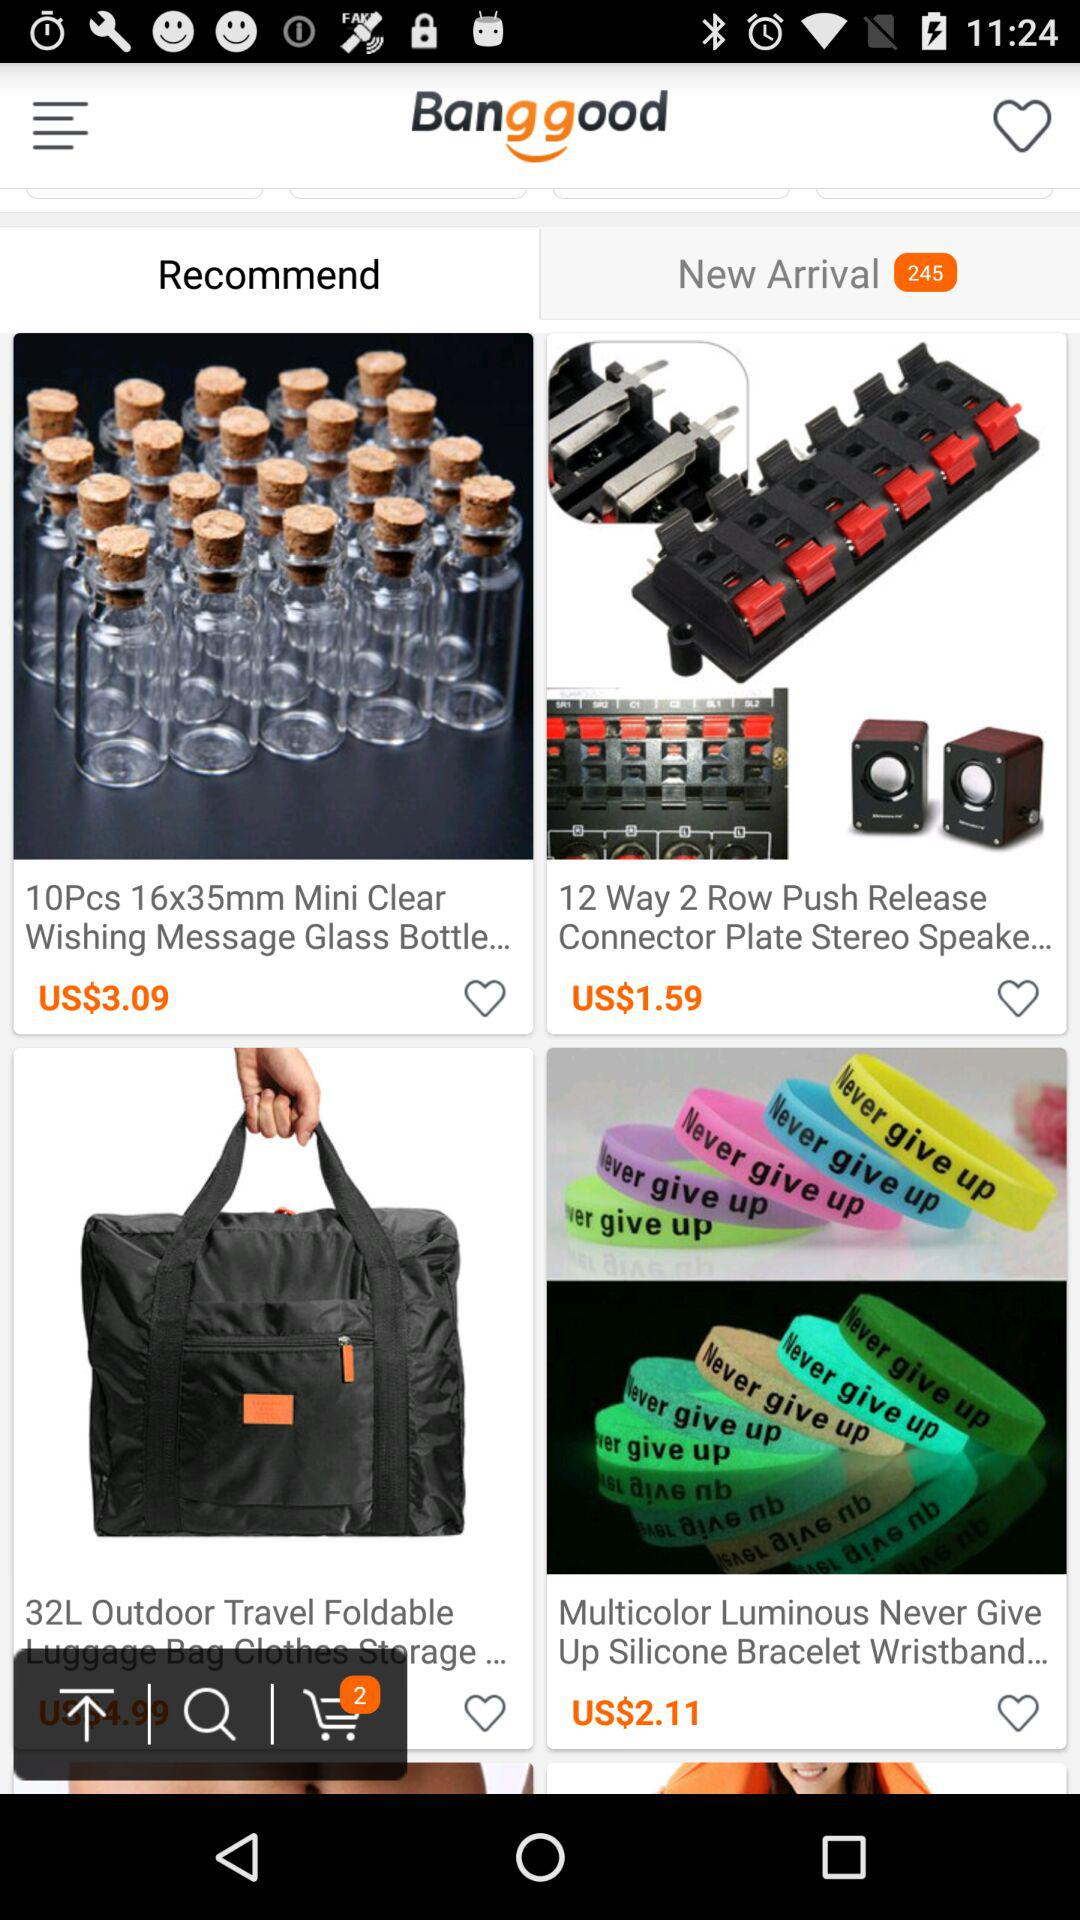How many silicone bracelets are there?
When the provided information is insufficient, respond with <no answer>. <no answer> 